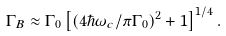Convert formula to latex. <formula><loc_0><loc_0><loc_500><loc_500>\Gamma _ { B } \approx \Gamma _ { 0 } \left [ \left ( 4 \hbar { \omega } _ { c } / \pi \Gamma _ { 0 } \right ) ^ { 2 } + 1 \right ] ^ { 1 / 4 } .</formula> 